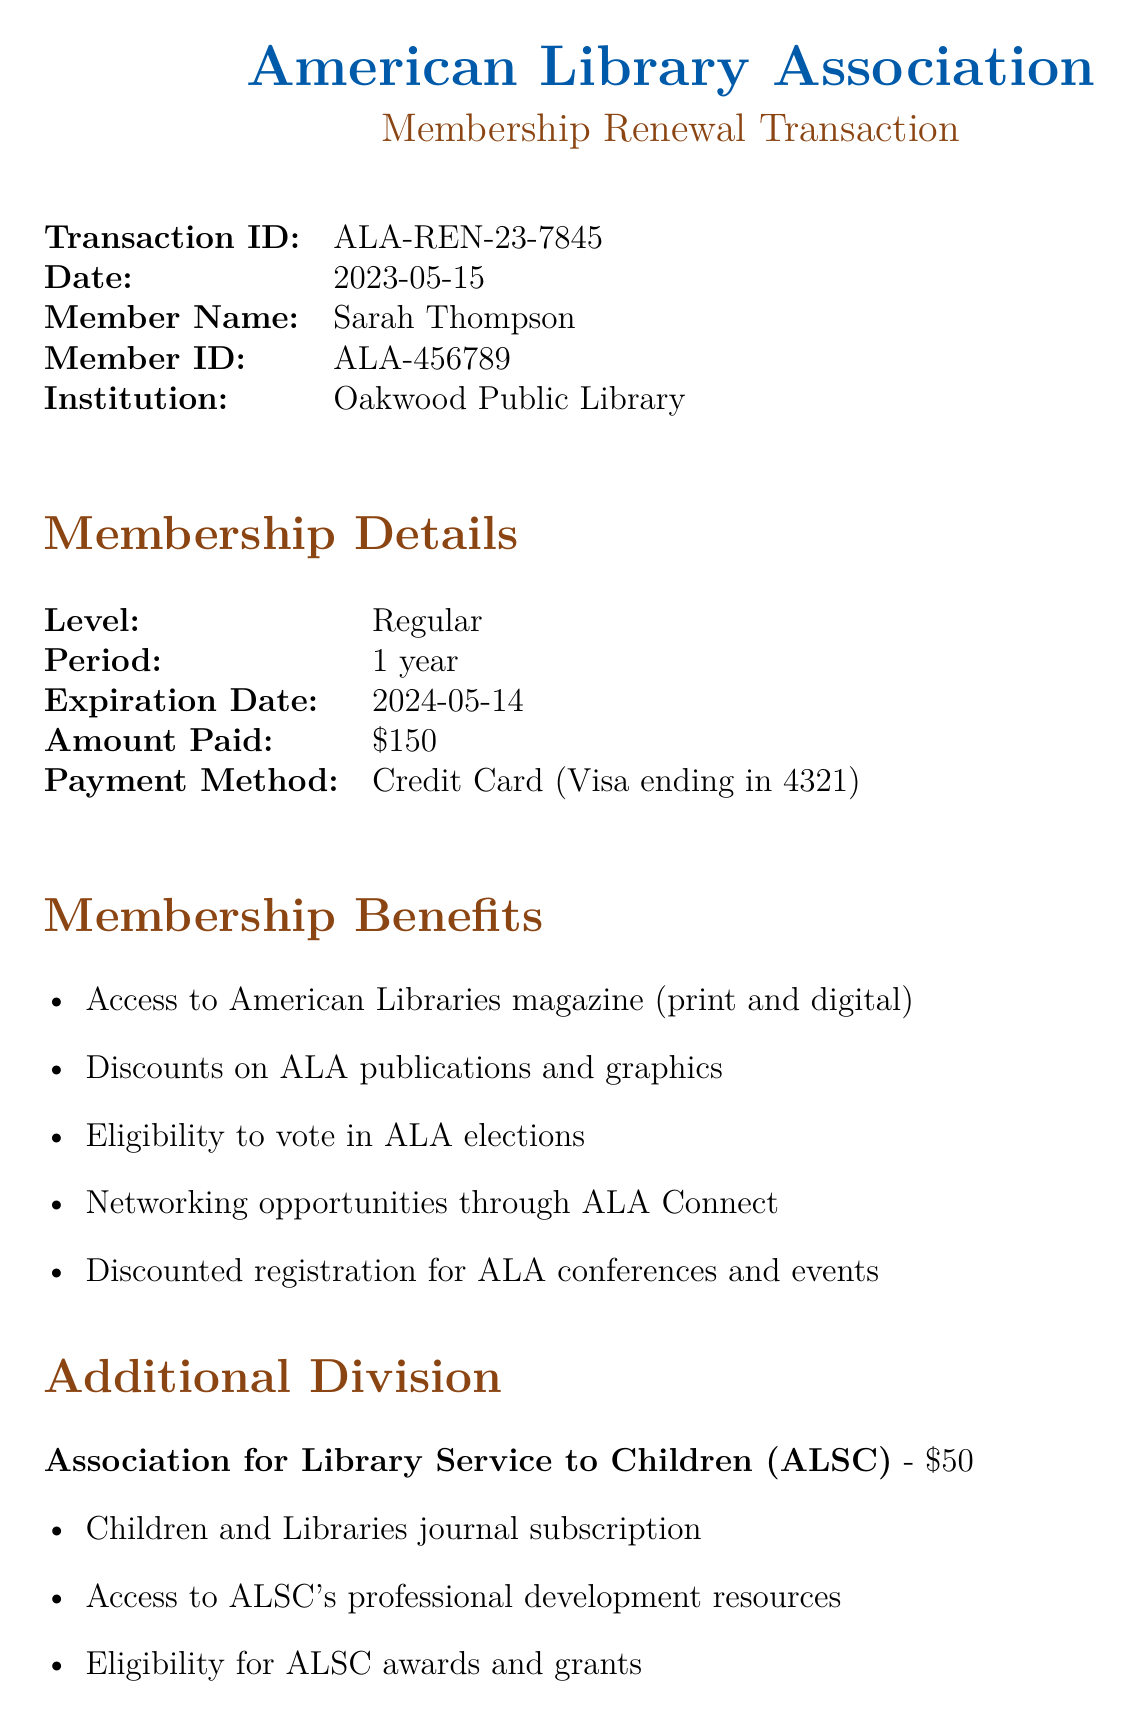What is the transaction ID? The transaction ID is provided in the document as a unique identifier for this transaction.
Answer: ALA-REN-23-7845 Who is the member renewing the membership? The document includes a specific section that identifies the member's name renewing their membership.
Answer: Sarah Thompson What is the membership level? The membership level indicates the type of membership that was renewed and is clearly stated in the document.
Answer: Regular When does the membership expire? The expiration date signifies when the current membership will end, and this date is specified in the membership details.
Answer: 2024-05-14 How much was paid for the membership? The amount paid is stated explicitly in the membership details, indicating the financial aspect of the transaction.
Answer: $150 What additional division is mentioned? The document lists any optional divisions or sections that can be added to the membership, and one such division is indicated.
Answer: Association for Library Service to Children (ALSC) What is one benefit of the Regular membership? The benefits list enumerates the perks that come along with the Regular membership, covering several advantages.
Answer: Access to American Libraries magazine (print and digital) How many CEU credits does the Historical Fiction workshop offer? The CEU credits signify the educational value of the workshop and are mentioned next to the corresponding event.
Answer: 3 CEU What is the special note referred to in the document? The special note addresses specific information relevant to the member's background or interests, explicitly stated in the document.
Answer: As a former history teacher, you may be interested in our upcoming webinar series on 'Incorporating Primary Sources in Children's History Programs' starting in October 2023 